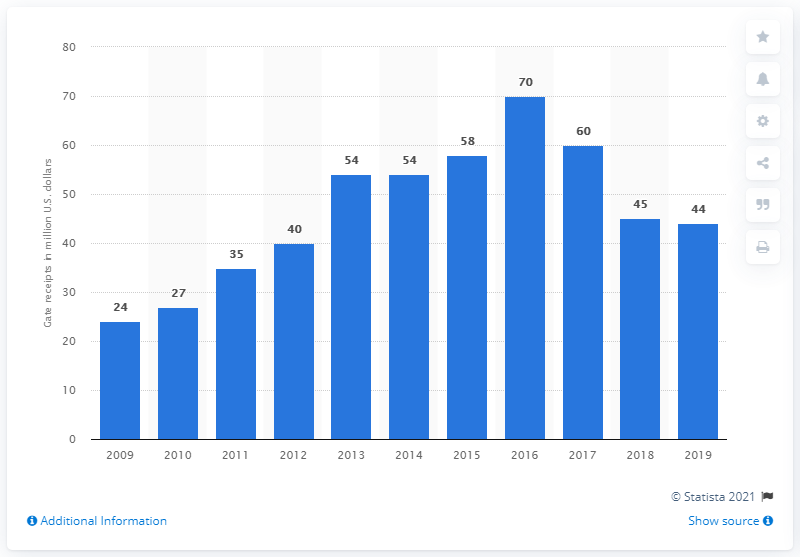List a handful of essential elements in this visual. The gate receipts of the Pittsburgh Pirates in 2019 were 44 dollars. 